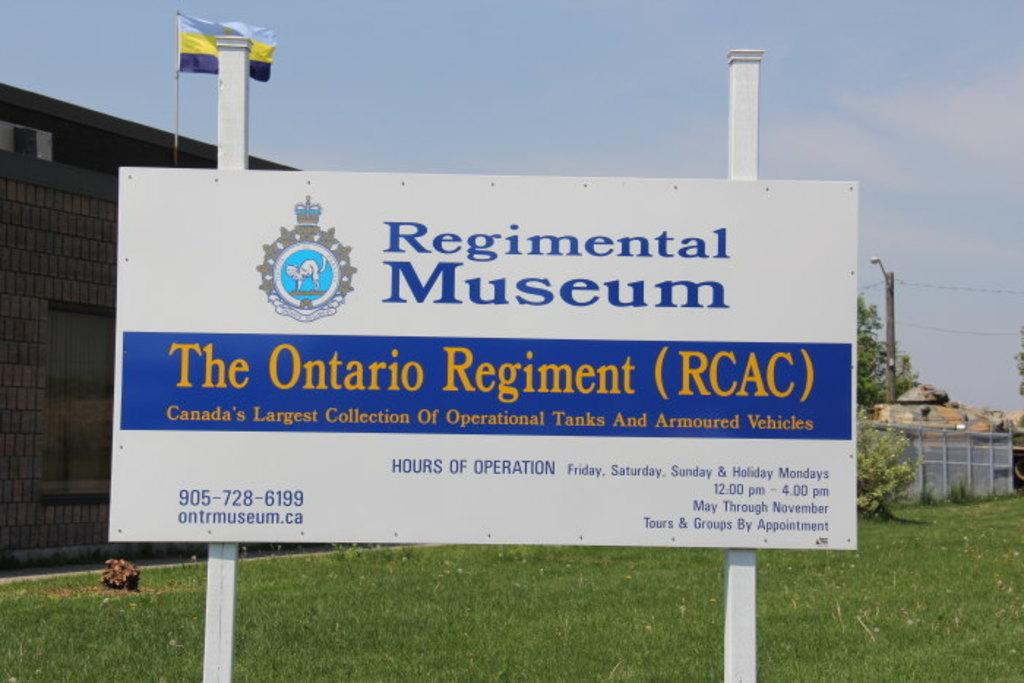<image>
Give a short and clear explanation of the subsequent image. A museum sign contains the word Ontario on it. 